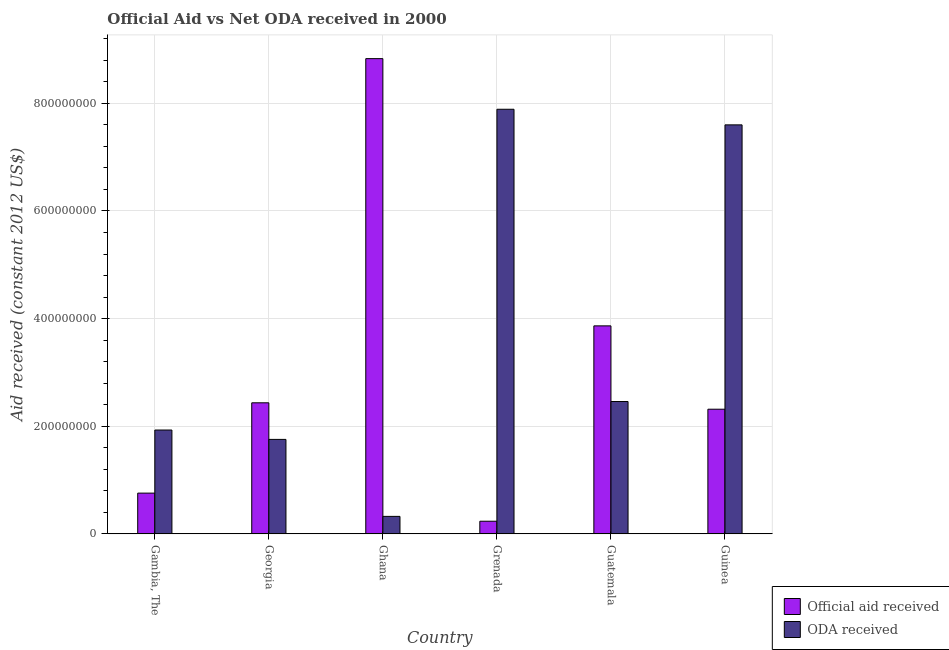How many different coloured bars are there?
Provide a short and direct response. 2. Are the number of bars per tick equal to the number of legend labels?
Give a very brief answer. Yes. Are the number of bars on each tick of the X-axis equal?
Ensure brevity in your answer.  Yes. In how many cases, is the number of bars for a given country not equal to the number of legend labels?
Your answer should be compact. 0. What is the official aid received in Guinea?
Provide a short and direct response. 2.32e+08. Across all countries, what is the maximum oda received?
Provide a succinct answer. 7.89e+08. Across all countries, what is the minimum official aid received?
Make the answer very short. 2.35e+07. In which country was the oda received maximum?
Provide a succinct answer. Grenada. In which country was the oda received minimum?
Ensure brevity in your answer.  Ghana. What is the total official aid received in the graph?
Ensure brevity in your answer.  1.84e+09. What is the difference between the official aid received in Guatemala and that in Guinea?
Your answer should be very brief. 1.55e+08. What is the difference between the official aid received in Gambia, The and the oda received in Guatemala?
Keep it short and to the point. -1.70e+08. What is the average official aid received per country?
Give a very brief answer. 3.07e+08. What is the difference between the oda received and official aid received in Gambia, The?
Keep it short and to the point. 1.17e+08. In how many countries, is the official aid received greater than 600000000 US$?
Your answer should be compact. 1. What is the ratio of the oda received in Georgia to that in Grenada?
Keep it short and to the point. 0.22. Is the oda received in Gambia, The less than that in Guatemala?
Make the answer very short. Yes. Is the difference between the official aid received in Gambia, The and Grenada greater than the difference between the oda received in Gambia, The and Grenada?
Your response must be concise. Yes. What is the difference between the highest and the second highest oda received?
Ensure brevity in your answer.  2.90e+07. What is the difference between the highest and the lowest oda received?
Your answer should be compact. 7.56e+08. What does the 1st bar from the left in Gambia, The represents?
Give a very brief answer. Official aid received. What does the 2nd bar from the right in Guatemala represents?
Offer a very short reply. Official aid received. Are the values on the major ticks of Y-axis written in scientific E-notation?
Your response must be concise. No. Does the graph contain grids?
Ensure brevity in your answer.  Yes. Where does the legend appear in the graph?
Ensure brevity in your answer.  Bottom right. How are the legend labels stacked?
Ensure brevity in your answer.  Vertical. What is the title of the graph?
Offer a terse response. Official Aid vs Net ODA received in 2000 . What is the label or title of the Y-axis?
Give a very brief answer. Aid received (constant 2012 US$). What is the Aid received (constant 2012 US$) in Official aid received in Gambia, The?
Provide a succinct answer. 7.57e+07. What is the Aid received (constant 2012 US$) in ODA received in Gambia, The?
Provide a short and direct response. 1.93e+08. What is the Aid received (constant 2012 US$) in Official aid received in Georgia?
Make the answer very short. 2.44e+08. What is the Aid received (constant 2012 US$) in ODA received in Georgia?
Your response must be concise. 1.76e+08. What is the Aid received (constant 2012 US$) of Official aid received in Ghana?
Your response must be concise. 8.83e+08. What is the Aid received (constant 2012 US$) in ODA received in Ghana?
Ensure brevity in your answer.  3.25e+07. What is the Aid received (constant 2012 US$) of Official aid received in Grenada?
Your answer should be compact. 2.35e+07. What is the Aid received (constant 2012 US$) in ODA received in Grenada?
Offer a very short reply. 7.89e+08. What is the Aid received (constant 2012 US$) in Official aid received in Guatemala?
Keep it short and to the point. 3.86e+08. What is the Aid received (constant 2012 US$) in ODA received in Guatemala?
Offer a terse response. 2.46e+08. What is the Aid received (constant 2012 US$) in Official aid received in Guinea?
Your answer should be compact. 2.32e+08. What is the Aid received (constant 2012 US$) in ODA received in Guinea?
Provide a short and direct response. 7.60e+08. Across all countries, what is the maximum Aid received (constant 2012 US$) of Official aid received?
Provide a succinct answer. 8.83e+08. Across all countries, what is the maximum Aid received (constant 2012 US$) of ODA received?
Ensure brevity in your answer.  7.89e+08. Across all countries, what is the minimum Aid received (constant 2012 US$) of Official aid received?
Make the answer very short. 2.35e+07. Across all countries, what is the minimum Aid received (constant 2012 US$) in ODA received?
Make the answer very short. 3.25e+07. What is the total Aid received (constant 2012 US$) in Official aid received in the graph?
Make the answer very short. 1.84e+09. What is the total Aid received (constant 2012 US$) of ODA received in the graph?
Provide a short and direct response. 2.20e+09. What is the difference between the Aid received (constant 2012 US$) in Official aid received in Gambia, The and that in Georgia?
Keep it short and to the point. -1.68e+08. What is the difference between the Aid received (constant 2012 US$) in ODA received in Gambia, The and that in Georgia?
Give a very brief answer. 1.74e+07. What is the difference between the Aid received (constant 2012 US$) of Official aid received in Gambia, The and that in Ghana?
Your response must be concise. -8.07e+08. What is the difference between the Aid received (constant 2012 US$) in ODA received in Gambia, The and that in Ghana?
Offer a terse response. 1.60e+08. What is the difference between the Aid received (constant 2012 US$) in Official aid received in Gambia, The and that in Grenada?
Your answer should be compact. 5.22e+07. What is the difference between the Aid received (constant 2012 US$) of ODA received in Gambia, The and that in Grenada?
Give a very brief answer. -5.96e+08. What is the difference between the Aid received (constant 2012 US$) in Official aid received in Gambia, The and that in Guatemala?
Your response must be concise. -3.11e+08. What is the difference between the Aid received (constant 2012 US$) in ODA received in Gambia, The and that in Guatemala?
Provide a short and direct response. -5.30e+07. What is the difference between the Aid received (constant 2012 US$) of Official aid received in Gambia, The and that in Guinea?
Offer a very short reply. -1.56e+08. What is the difference between the Aid received (constant 2012 US$) in ODA received in Gambia, The and that in Guinea?
Give a very brief answer. -5.67e+08. What is the difference between the Aid received (constant 2012 US$) in Official aid received in Georgia and that in Ghana?
Give a very brief answer. -6.39e+08. What is the difference between the Aid received (constant 2012 US$) in ODA received in Georgia and that in Ghana?
Give a very brief answer. 1.43e+08. What is the difference between the Aid received (constant 2012 US$) of Official aid received in Georgia and that in Grenada?
Your answer should be very brief. 2.20e+08. What is the difference between the Aid received (constant 2012 US$) in ODA received in Georgia and that in Grenada?
Your answer should be very brief. -6.13e+08. What is the difference between the Aid received (constant 2012 US$) in Official aid received in Georgia and that in Guatemala?
Offer a very short reply. -1.43e+08. What is the difference between the Aid received (constant 2012 US$) of ODA received in Georgia and that in Guatemala?
Ensure brevity in your answer.  -7.04e+07. What is the difference between the Aid received (constant 2012 US$) in Official aid received in Georgia and that in Guinea?
Offer a very short reply. 1.19e+07. What is the difference between the Aid received (constant 2012 US$) of ODA received in Georgia and that in Guinea?
Offer a very short reply. -5.84e+08. What is the difference between the Aid received (constant 2012 US$) of Official aid received in Ghana and that in Grenada?
Your answer should be compact. 8.60e+08. What is the difference between the Aid received (constant 2012 US$) of ODA received in Ghana and that in Grenada?
Make the answer very short. -7.56e+08. What is the difference between the Aid received (constant 2012 US$) of Official aid received in Ghana and that in Guatemala?
Provide a succinct answer. 4.97e+08. What is the difference between the Aid received (constant 2012 US$) in ODA received in Ghana and that in Guatemala?
Your response must be concise. -2.13e+08. What is the difference between the Aid received (constant 2012 US$) of Official aid received in Ghana and that in Guinea?
Make the answer very short. 6.51e+08. What is the difference between the Aid received (constant 2012 US$) of ODA received in Ghana and that in Guinea?
Your answer should be very brief. -7.27e+08. What is the difference between the Aid received (constant 2012 US$) of Official aid received in Grenada and that in Guatemala?
Provide a short and direct response. -3.63e+08. What is the difference between the Aid received (constant 2012 US$) of ODA received in Grenada and that in Guatemala?
Your answer should be compact. 5.43e+08. What is the difference between the Aid received (constant 2012 US$) of Official aid received in Grenada and that in Guinea?
Your answer should be compact. -2.08e+08. What is the difference between the Aid received (constant 2012 US$) in ODA received in Grenada and that in Guinea?
Your answer should be very brief. 2.90e+07. What is the difference between the Aid received (constant 2012 US$) of Official aid received in Guatemala and that in Guinea?
Your answer should be very brief. 1.55e+08. What is the difference between the Aid received (constant 2012 US$) in ODA received in Guatemala and that in Guinea?
Your answer should be compact. -5.14e+08. What is the difference between the Aid received (constant 2012 US$) in Official aid received in Gambia, The and the Aid received (constant 2012 US$) in ODA received in Georgia?
Your response must be concise. -9.98e+07. What is the difference between the Aid received (constant 2012 US$) of Official aid received in Gambia, The and the Aid received (constant 2012 US$) of ODA received in Ghana?
Your answer should be compact. 4.32e+07. What is the difference between the Aid received (constant 2012 US$) in Official aid received in Gambia, The and the Aid received (constant 2012 US$) in ODA received in Grenada?
Keep it short and to the point. -7.13e+08. What is the difference between the Aid received (constant 2012 US$) in Official aid received in Gambia, The and the Aid received (constant 2012 US$) in ODA received in Guatemala?
Your answer should be compact. -1.70e+08. What is the difference between the Aid received (constant 2012 US$) in Official aid received in Gambia, The and the Aid received (constant 2012 US$) in ODA received in Guinea?
Offer a very short reply. -6.84e+08. What is the difference between the Aid received (constant 2012 US$) in Official aid received in Georgia and the Aid received (constant 2012 US$) in ODA received in Ghana?
Provide a short and direct response. 2.11e+08. What is the difference between the Aid received (constant 2012 US$) of Official aid received in Georgia and the Aid received (constant 2012 US$) of ODA received in Grenada?
Provide a succinct answer. -5.45e+08. What is the difference between the Aid received (constant 2012 US$) in Official aid received in Georgia and the Aid received (constant 2012 US$) in ODA received in Guatemala?
Your response must be concise. -2.37e+06. What is the difference between the Aid received (constant 2012 US$) of Official aid received in Georgia and the Aid received (constant 2012 US$) of ODA received in Guinea?
Keep it short and to the point. -5.16e+08. What is the difference between the Aid received (constant 2012 US$) in Official aid received in Ghana and the Aid received (constant 2012 US$) in ODA received in Grenada?
Make the answer very short. 9.41e+07. What is the difference between the Aid received (constant 2012 US$) in Official aid received in Ghana and the Aid received (constant 2012 US$) in ODA received in Guatemala?
Provide a succinct answer. 6.37e+08. What is the difference between the Aid received (constant 2012 US$) in Official aid received in Ghana and the Aid received (constant 2012 US$) in ODA received in Guinea?
Offer a very short reply. 1.23e+08. What is the difference between the Aid received (constant 2012 US$) in Official aid received in Grenada and the Aid received (constant 2012 US$) in ODA received in Guatemala?
Your response must be concise. -2.22e+08. What is the difference between the Aid received (constant 2012 US$) in Official aid received in Grenada and the Aid received (constant 2012 US$) in ODA received in Guinea?
Your response must be concise. -7.36e+08. What is the difference between the Aid received (constant 2012 US$) in Official aid received in Guatemala and the Aid received (constant 2012 US$) in ODA received in Guinea?
Offer a very short reply. -3.73e+08. What is the average Aid received (constant 2012 US$) in Official aid received per country?
Make the answer very short. 3.07e+08. What is the average Aid received (constant 2012 US$) of ODA received per country?
Offer a very short reply. 3.66e+08. What is the difference between the Aid received (constant 2012 US$) in Official aid received and Aid received (constant 2012 US$) in ODA received in Gambia, The?
Ensure brevity in your answer.  -1.17e+08. What is the difference between the Aid received (constant 2012 US$) of Official aid received and Aid received (constant 2012 US$) of ODA received in Georgia?
Ensure brevity in your answer.  6.80e+07. What is the difference between the Aid received (constant 2012 US$) of Official aid received and Aid received (constant 2012 US$) of ODA received in Ghana?
Your answer should be compact. 8.51e+08. What is the difference between the Aid received (constant 2012 US$) of Official aid received and Aid received (constant 2012 US$) of ODA received in Grenada?
Your answer should be very brief. -7.65e+08. What is the difference between the Aid received (constant 2012 US$) of Official aid received and Aid received (constant 2012 US$) of ODA received in Guatemala?
Provide a succinct answer. 1.41e+08. What is the difference between the Aid received (constant 2012 US$) of Official aid received and Aid received (constant 2012 US$) of ODA received in Guinea?
Provide a succinct answer. -5.28e+08. What is the ratio of the Aid received (constant 2012 US$) in Official aid received in Gambia, The to that in Georgia?
Your answer should be very brief. 0.31. What is the ratio of the Aid received (constant 2012 US$) in ODA received in Gambia, The to that in Georgia?
Offer a very short reply. 1.1. What is the ratio of the Aid received (constant 2012 US$) in Official aid received in Gambia, The to that in Ghana?
Provide a short and direct response. 0.09. What is the ratio of the Aid received (constant 2012 US$) in ODA received in Gambia, The to that in Ghana?
Ensure brevity in your answer.  5.94. What is the ratio of the Aid received (constant 2012 US$) of Official aid received in Gambia, The to that in Grenada?
Offer a very short reply. 3.22. What is the ratio of the Aid received (constant 2012 US$) in ODA received in Gambia, The to that in Grenada?
Provide a short and direct response. 0.24. What is the ratio of the Aid received (constant 2012 US$) of Official aid received in Gambia, The to that in Guatemala?
Make the answer very short. 0.2. What is the ratio of the Aid received (constant 2012 US$) of ODA received in Gambia, The to that in Guatemala?
Make the answer very short. 0.78. What is the ratio of the Aid received (constant 2012 US$) of Official aid received in Gambia, The to that in Guinea?
Offer a terse response. 0.33. What is the ratio of the Aid received (constant 2012 US$) of ODA received in Gambia, The to that in Guinea?
Ensure brevity in your answer.  0.25. What is the ratio of the Aid received (constant 2012 US$) in Official aid received in Georgia to that in Ghana?
Ensure brevity in your answer.  0.28. What is the ratio of the Aid received (constant 2012 US$) of ODA received in Georgia to that in Ghana?
Ensure brevity in your answer.  5.4. What is the ratio of the Aid received (constant 2012 US$) of Official aid received in Georgia to that in Grenada?
Make the answer very short. 10.37. What is the ratio of the Aid received (constant 2012 US$) in ODA received in Georgia to that in Grenada?
Provide a short and direct response. 0.22. What is the ratio of the Aid received (constant 2012 US$) in Official aid received in Georgia to that in Guatemala?
Give a very brief answer. 0.63. What is the ratio of the Aid received (constant 2012 US$) in ODA received in Georgia to that in Guatemala?
Provide a succinct answer. 0.71. What is the ratio of the Aid received (constant 2012 US$) of Official aid received in Georgia to that in Guinea?
Ensure brevity in your answer.  1.05. What is the ratio of the Aid received (constant 2012 US$) in ODA received in Georgia to that in Guinea?
Offer a terse response. 0.23. What is the ratio of the Aid received (constant 2012 US$) of Official aid received in Ghana to that in Grenada?
Ensure brevity in your answer.  37.61. What is the ratio of the Aid received (constant 2012 US$) of ODA received in Ghana to that in Grenada?
Offer a very short reply. 0.04. What is the ratio of the Aid received (constant 2012 US$) of Official aid received in Ghana to that in Guatemala?
Give a very brief answer. 2.28. What is the ratio of the Aid received (constant 2012 US$) in ODA received in Ghana to that in Guatemala?
Provide a succinct answer. 0.13. What is the ratio of the Aid received (constant 2012 US$) in Official aid received in Ghana to that in Guinea?
Provide a succinct answer. 3.81. What is the ratio of the Aid received (constant 2012 US$) in ODA received in Ghana to that in Guinea?
Give a very brief answer. 0.04. What is the ratio of the Aid received (constant 2012 US$) of Official aid received in Grenada to that in Guatemala?
Provide a succinct answer. 0.06. What is the ratio of the Aid received (constant 2012 US$) in ODA received in Grenada to that in Guatemala?
Your answer should be very brief. 3.21. What is the ratio of the Aid received (constant 2012 US$) of Official aid received in Grenada to that in Guinea?
Your response must be concise. 0.1. What is the ratio of the Aid received (constant 2012 US$) of ODA received in Grenada to that in Guinea?
Offer a terse response. 1.04. What is the ratio of the Aid received (constant 2012 US$) of Official aid received in Guatemala to that in Guinea?
Keep it short and to the point. 1.67. What is the ratio of the Aid received (constant 2012 US$) of ODA received in Guatemala to that in Guinea?
Offer a terse response. 0.32. What is the difference between the highest and the second highest Aid received (constant 2012 US$) in Official aid received?
Provide a succinct answer. 4.97e+08. What is the difference between the highest and the second highest Aid received (constant 2012 US$) of ODA received?
Offer a terse response. 2.90e+07. What is the difference between the highest and the lowest Aid received (constant 2012 US$) in Official aid received?
Offer a very short reply. 8.60e+08. What is the difference between the highest and the lowest Aid received (constant 2012 US$) of ODA received?
Your response must be concise. 7.56e+08. 